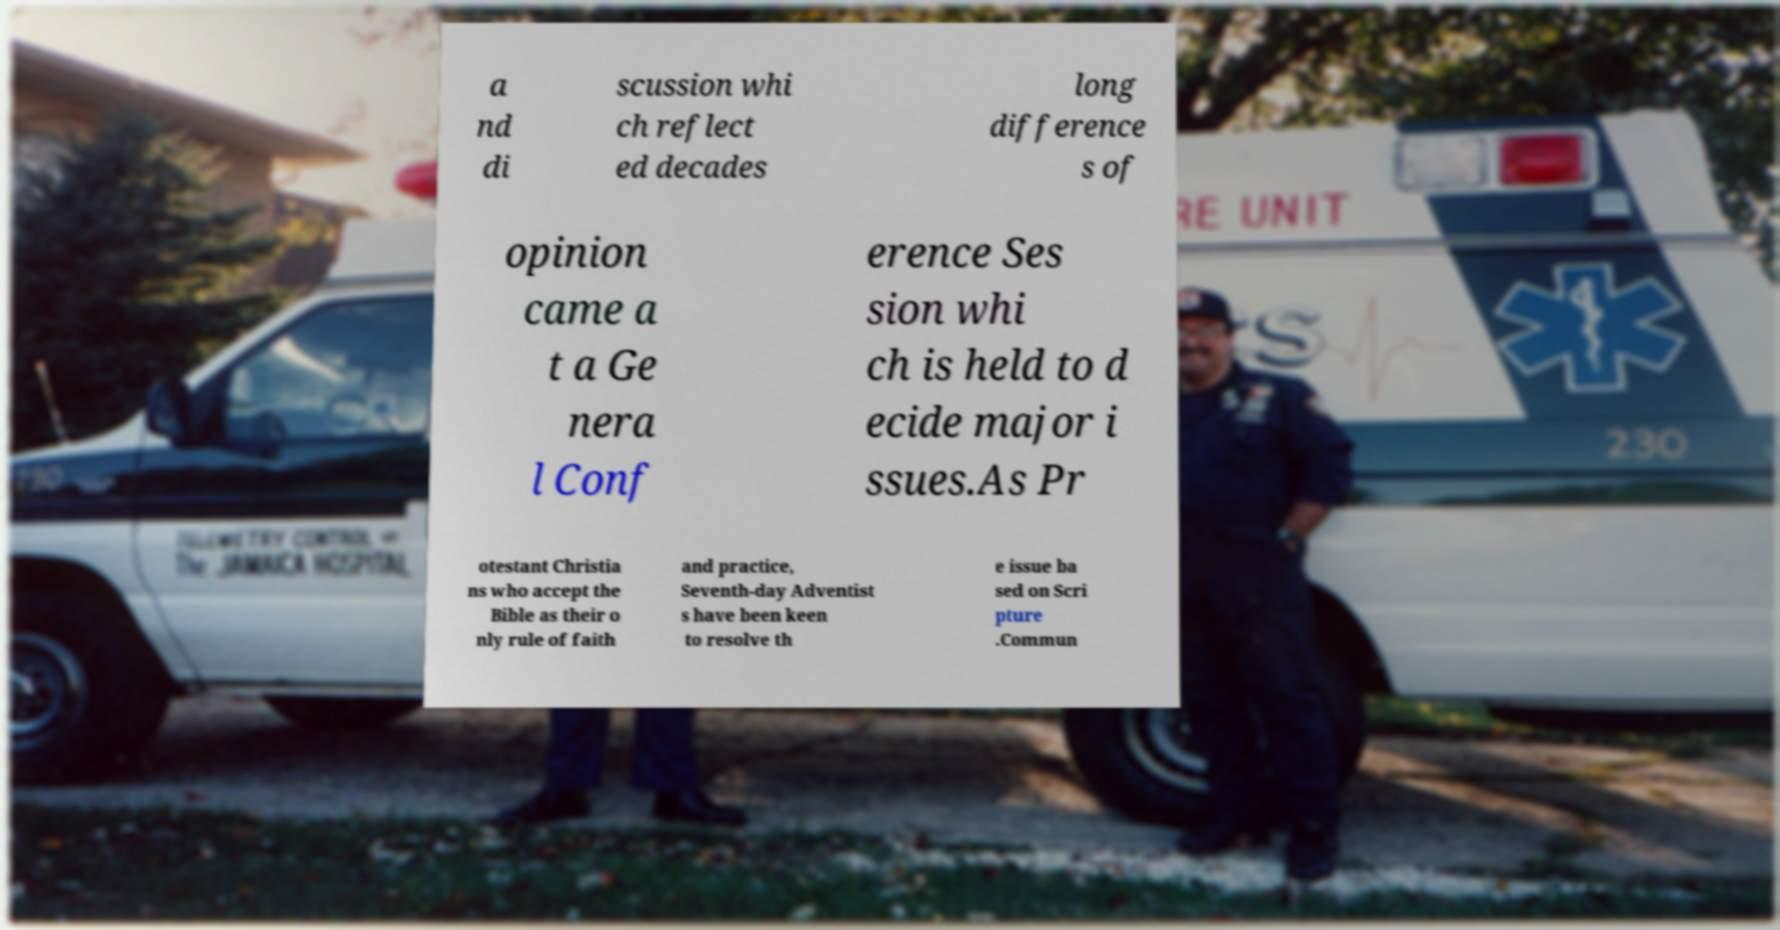Can you accurately transcribe the text from the provided image for me? a nd di scussion whi ch reflect ed decades long difference s of opinion came a t a Ge nera l Conf erence Ses sion whi ch is held to d ecide major i ssues.As Pr otestant Christia ns who accept the Bible as their o nly rule of faith and practice, Seventh-day Adventist s have been keen to resolve th e issue ba sed on Scri pture .Commun 